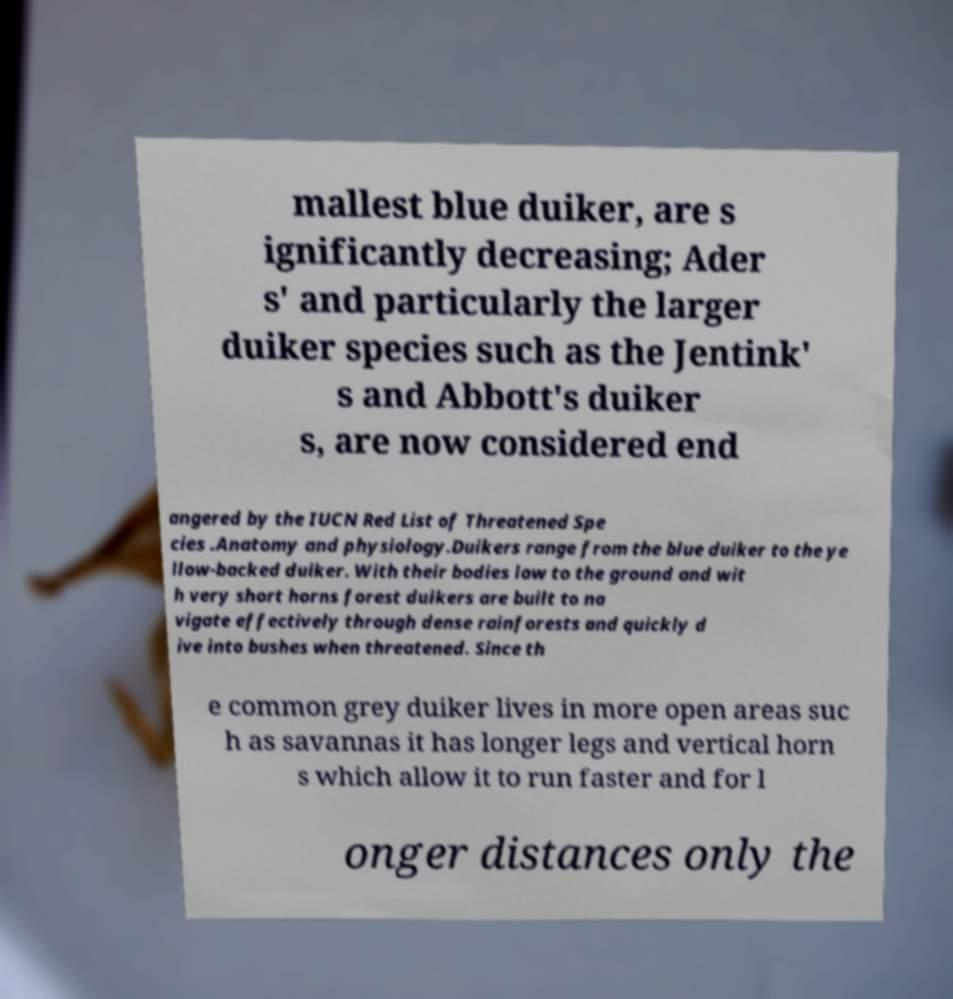Please read and relay the text visible in this image. What does it say? mallest blue duiker, are s ignificantly decreasing; Ader s' and particularly the larger duiker species such as the Jentink' s and Abbott's duiker s, are now considered end angered by the IUCN Red List of Threatened Spe cies .Anatomy and physiology.Duikers range from the blue duiker to the ye llow-backed duiker. With their bodies low to the ground and wit h very short horns forest duikers are built to na vigate effectively through dense rainforests and quickly d ive into bushes when threatened. Since th e common grey duiker lives in more open areas suc h as savannas it has longer legs and vertical horn s which allow it to run faster and for l onger distances only the 